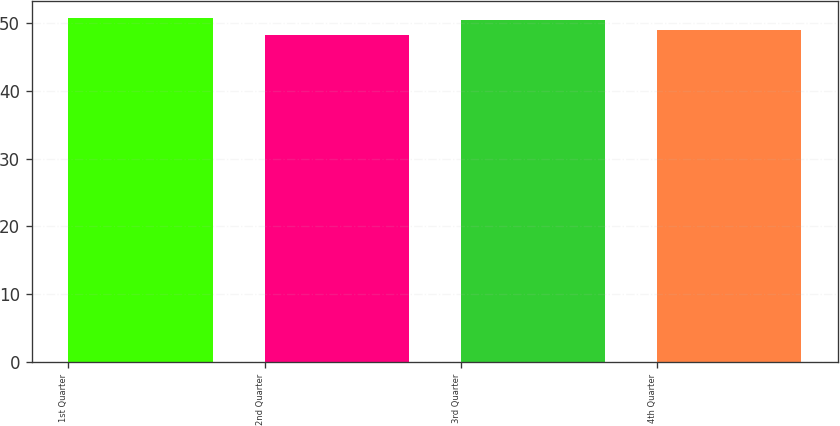Convert chart. <chart><loc_0><loc_0><loc_500><loc_500><bar_chart><fcel>1st Quarter<fcel>2nd Quarter<fcel>3rd Quarter<fcel>4th Quarter<nl><fcel>50.72<fcel>48.2<fcel>50.48<fcel>48.96<nl></chart> 